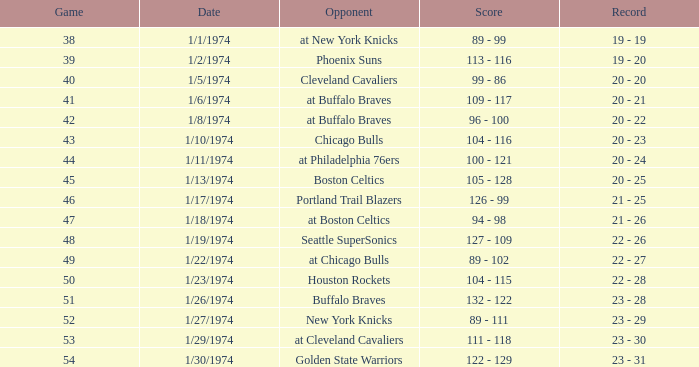Could you parse the entire table? {'header': ['Game', 'Date', 'Opponent', 'Score', 'Record'], 'rows': [['38', '1/1/1974', 'at New York Knicks', '89 - 99', '19 - 19'], ['39', '1/2/1974', 'Phoenix Suns', '113 - 116', '19 - 20'], ['40', '1/5/1974', 'Cleveland Cavaliers', '99 - 86', '20 - 20'], ['41', '1/6/1974', 'at Buffalo Braves', '109 - 117', '20 - 21'], ['42', '1/8/1974', 'at Buffalo Braves', '96 - 100', '20 - 22'], ['43', '1/10/1974', 'Chicago Bulls', '104 - 116', '20 - 23'], ['44', '1/11/1974', 'at Philadelphia 76ers', '100 - 121', '20 - 24'], ['45', '1/13/1974', 'Boston Celtics', '105 - 128', '20 - 25'], ['46', '1/17/1974', 'Portland Trail Blazers', '126 - 99', '21 - 25'], ['47', '1/18/1974', 'at Boston Celtics', '94 - 98', '21 - 26'], ['48', '1/19/1974', 'Seattle SuperSonics', '127 - 109', '22 - 26'], ['49', '1/22/1974', 'at Chicago Bulls', '89 - 102', '22 - 27'], ['50', '1/23/1974', 'Houston Rockets', '104 - 115', '22 - 28'], ['51', '1/26/1974', 'Buffalo Braves', '132 - 122', '23 - 28'], ['52', '1/27/1974', 'New York Knicks', '89 - 111', '23 - 29'], ['53', '1/29/1974', 'at Cleveland Cavaliers', '111 - 118', '23 - 30'], ['54', '1/30/1974', 'Golden State Warriors', '122 - 129', '23 - 31']]} What was the record after game 51 on 1/27/1974? 23 - 29. 